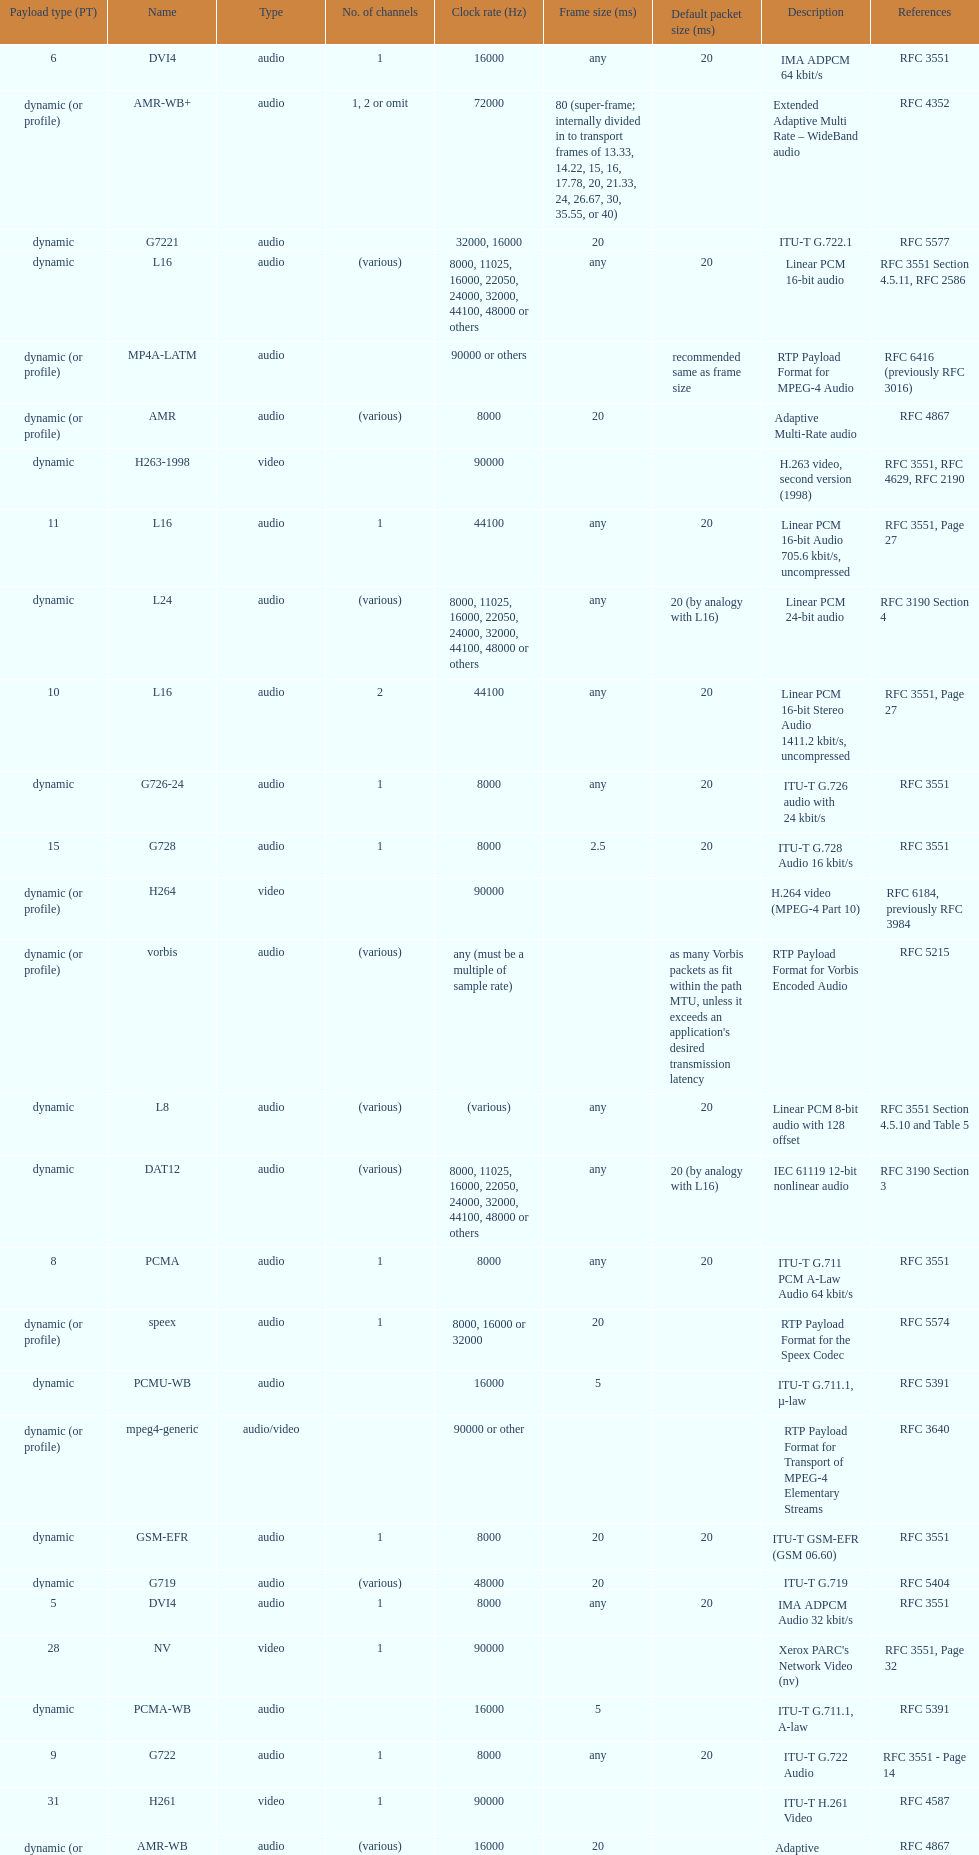The rtp/avp audio and video payload types include an audio type called qcelp and its frame size is how many ms? 20. 